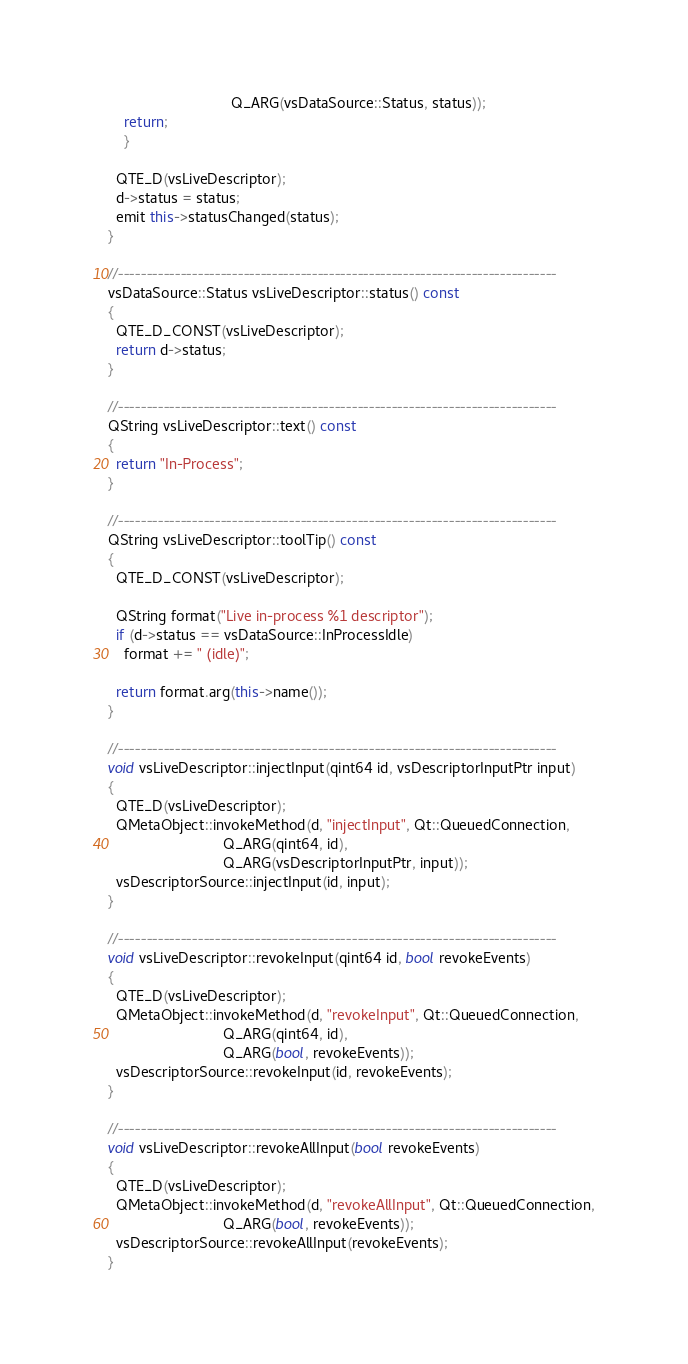<code> <loc_0><loc_0><loc_500><loc_500><_C++_>                              Q_ARG(vsDataSource::Status, status));
    return;
    }

  QTE_D(vsLiveDescriptor);
  d->status = status;
  emit this->statusChanged(status);
}

//-----------------------------------------------------------------------------
vsDataSource::Status vsLiveDescriptor::status() const
{
  QTE_D_CONST(vsLiveDescriptor);
  return d->status;
}

//-----------------------------------------------------------------------------
QString vsLiveDescriptor::text() const
{
  return "In-Process";
}

//-----------------------------------------------------------------------------
QString vsLiveDescriptor::toolTip() const
{
  QTE_D_CONST(vsLiveDescriptor);

  QString format("Live in-process %1 descriptor");
  if (d->status == vsDataSource::InProcessIdle)
    format += " (idle)";

  return format.arg(this->name());
}

//-----------------------------------------------------------------------------
void vsLiveDescriptor::injectInput(qint64 id, vsDescriptorInputPtr input)
{
  QTE_D(vsLiveDescriptor);
  QMetaObject::invokeMethod(d, "injectInput", Qt::QueuedConnection,
                            Q_ARG(qint64, id),
                            Q_ARG(vsDescriptorInputPtr, input));
  vsDescriptorSource::injectInput(id, input);
}

//-----------------------------------------------------------------------------
void vsLiveDescriptor::revokeInput(qint64 id, bool revokeEvents)
{
  QTE_D(vsLiveDescriptor);
  QMetaObject::invokeMethod(d, "revokeInput", Qt::QueuedConnection,
                            Q_ARG(qint64, id),
                            Q_ARG(bool, revokeEvents));
  vsDescriptorSource::revokeInput(id, revokeEvents);
}

//-----------------------------------------------------------------------------
void vsLiveDescriptor::revokeAllInput(bool revokeEvents)
{
  QTE_D(vsLiveDescriptor);
  QMetaObject::invokeMethod(d, "revokeAllInput", Qt::QueuedConnection,
                            Q_ARG(bool, revokeEvents));
  vsDescriptorSource::revokeAllInput(revokeEvents);
}
</code> 